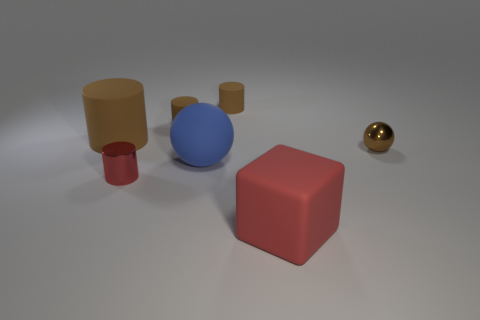Are there more small objects behind the tiny brown metal object than small balls that are to the left of the small red cylinder?
Ensure brevity in your answer.  Yes. There is a red object behind the red cube; is its size the same as the big matte cube?
Your answer should be very brief. No. There is a tiny rubber thing that is on the left side of the matte cylinder right of the matte ball; how many brown metallic things are on the left side of it?
Give a very brief answer. 0. There is a object that is in front of the large blue object and on the right side of the blue matte ball; how big is it?
Keep it short and to the point. Large. How many other objects are the same shape as the big red matte thing?
Keep it short and to the point. 0. What number of small brown rubber things are to the right of the tiny red metallic thing?
Your response must be concise. 2. Are there fewer large blue matte things that are right of the big red matte thing than tiny brown cylinders that are in front of the shiny sphere?
Ensure brevity in your answer.  No. There is a large object left of the tiny cylinder in front of the big thing that is behind the tiny sphere; what is its shape?
Keep it short and to the point. Cylinder. There is a big object that is both behind the big red block and in front of the big brown thing; what is its shape?
Your answer should be compact. Sphere. Are there any large things made of the same material as the tiny red cylinder?
Provide a succinct answer. No. 